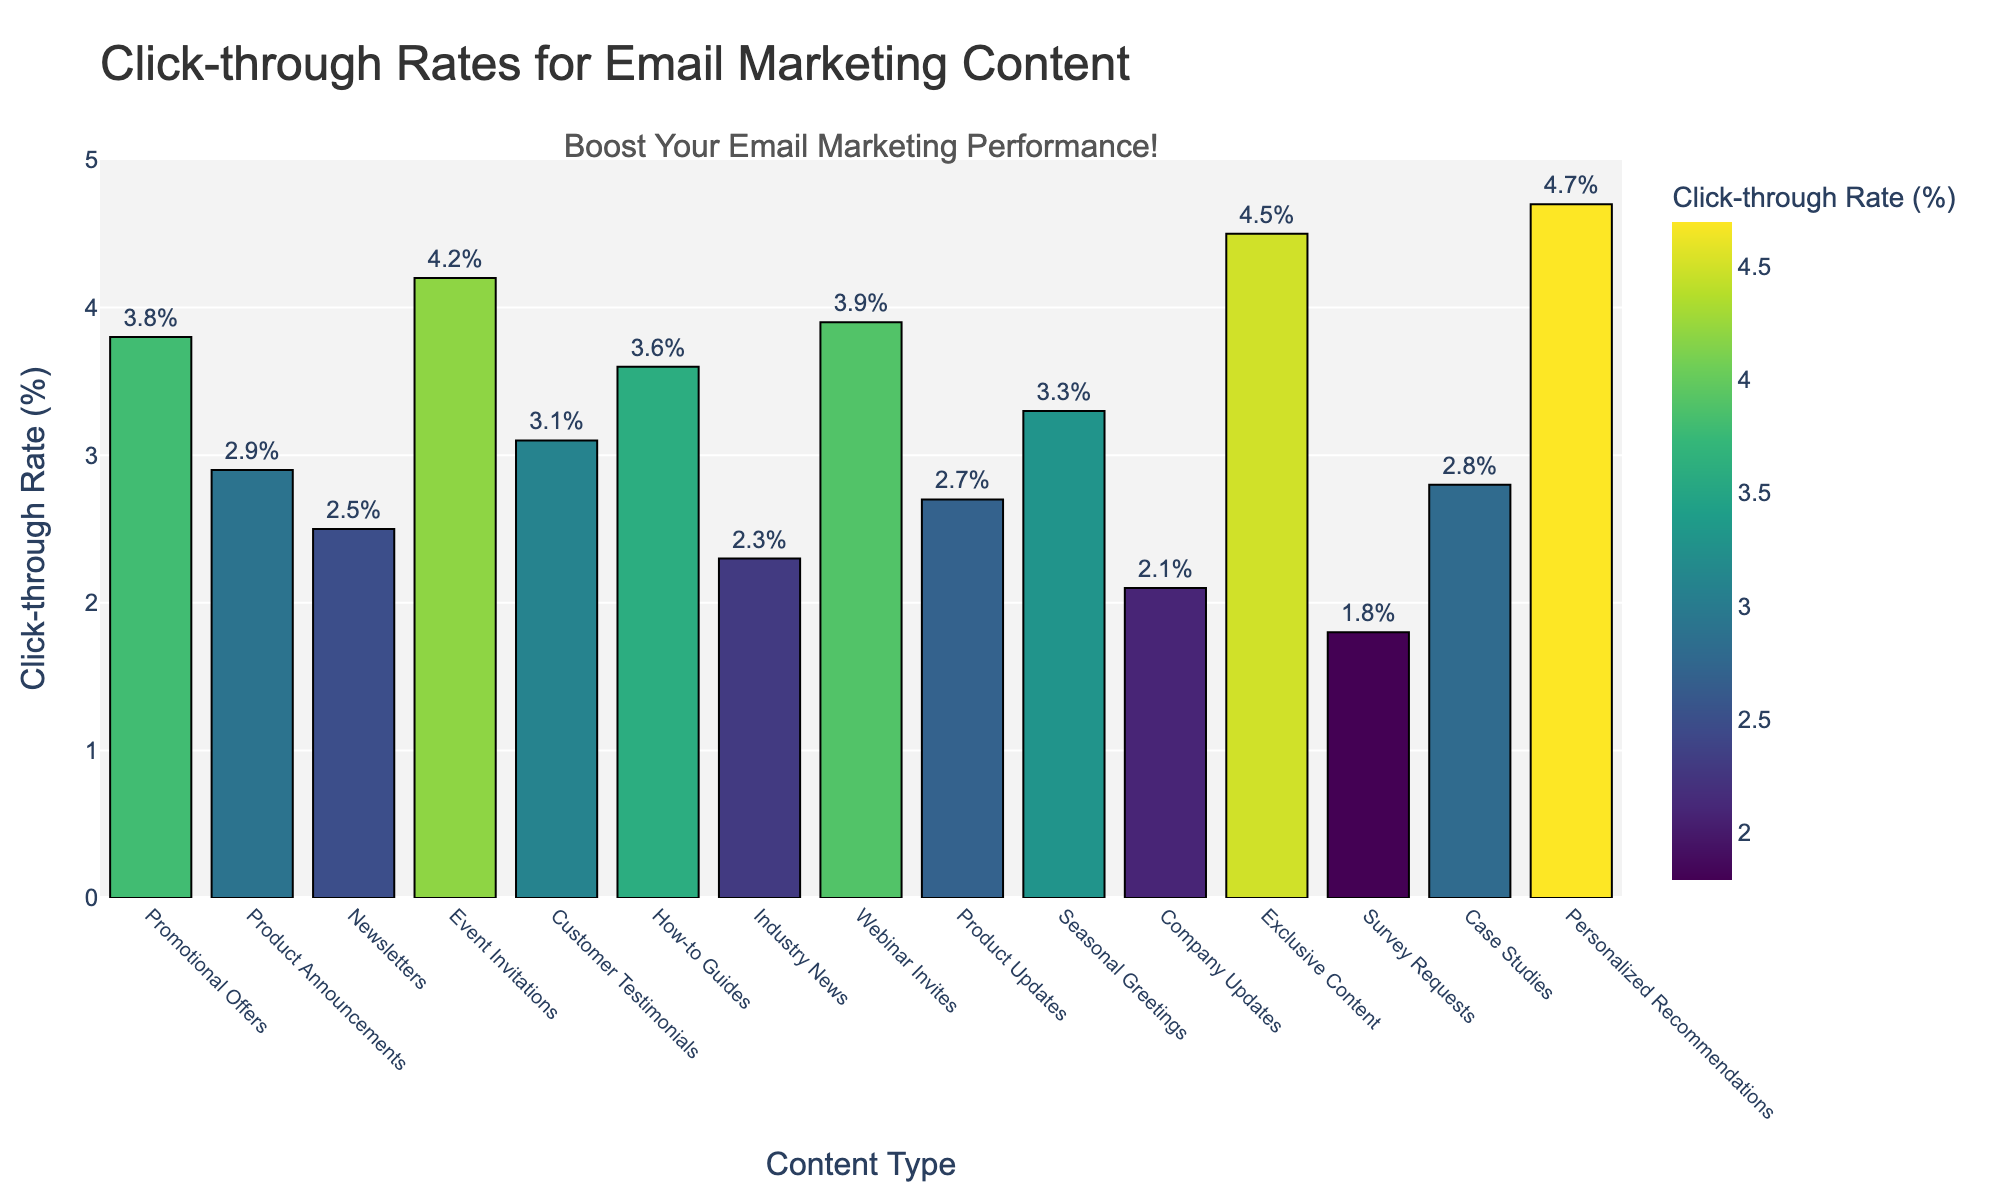Which content type has the highest click-through rate? Identify the tallest bar in the chart; the height corresponds to the click-through rate. "Personalized Recommendations" has the highest at 4.7%.
Answer: Personalized Recommendations Which content type has the lowest click-through rate? Identify the shortest bar in the chart, which corresponds to the lowest click-through rate. "Survey Requests" has the lowest at 1.8%.
Answer: Survey Requests Which content types have a click-through rate greater than 4%? Identify bars that reach above 4% on the y-axis. These include "Event Invitations" (4.2%), "Webinar Invites" (3.9%), "Exclusive Content" (4.5%), and "Personalized Recommendations" (4.7%).
Answer: Event Invitations, Exclusive Content, Personalized Recommendations What is the difference in click-through rate between "Promotional Offers" and "Company Updates"? Subtract the click-through rate of "Company Updates" (2.1%) from "Promotional Offers" (3.8%). 3.8% - 2.1% = 1.7%.
Answer: 1.7% What is the average click-through rate of "Event Invitations," "Webinar Invites," and "Exclusive Content"? Sum their click-through rates and divide by 3: (4.2% + 3.9% + 4.5%) / 3 ≈ 4.2%.
Answer: 4.2% Are there more content types with a click-through rate above or below 3%? Count the number of bars above and below 3%. There are 9 types below and 6 above.
Answer: Below 3% What is the total click-through rate for "How-to Guides" and "Product Announcements"? Sum the click-through rates of these content types: 3.6% + 2.9% = 6.5%.
Answer: 6.5% Is "Industry News" more or less effective than "Newsletters" in terms of click-through rate? Compare the heights of the bars for "Industry News" (2.3%) and "Newsletters" (2.5%). "Newsletters" has a higher rate.
Answer: Less Which content type close to 3% click-through rate have the closest rate to "Seasonal Greetings"? Compare the rates near 3% to "Seasonal Greetings" (3.3%): "Promotional Offers" (3.8%), "Customer Testimonials" (3.1%), "Webinar Invites" (3.9%). Closest is "Customer Testimonials."
Answer: Customer Testimonials What is the median click-through rate of all content types? List all click-through rates in ascending order: [1.8, 2.1, 2.3, 2.5, 2.7, 2.8, 2.9, 3.1, 3.3, 3.6, 3.8, 3.9, 4.2, 4.5, 4.7]. The median (8th value) is 3.1%.
Answer: 3.1% 